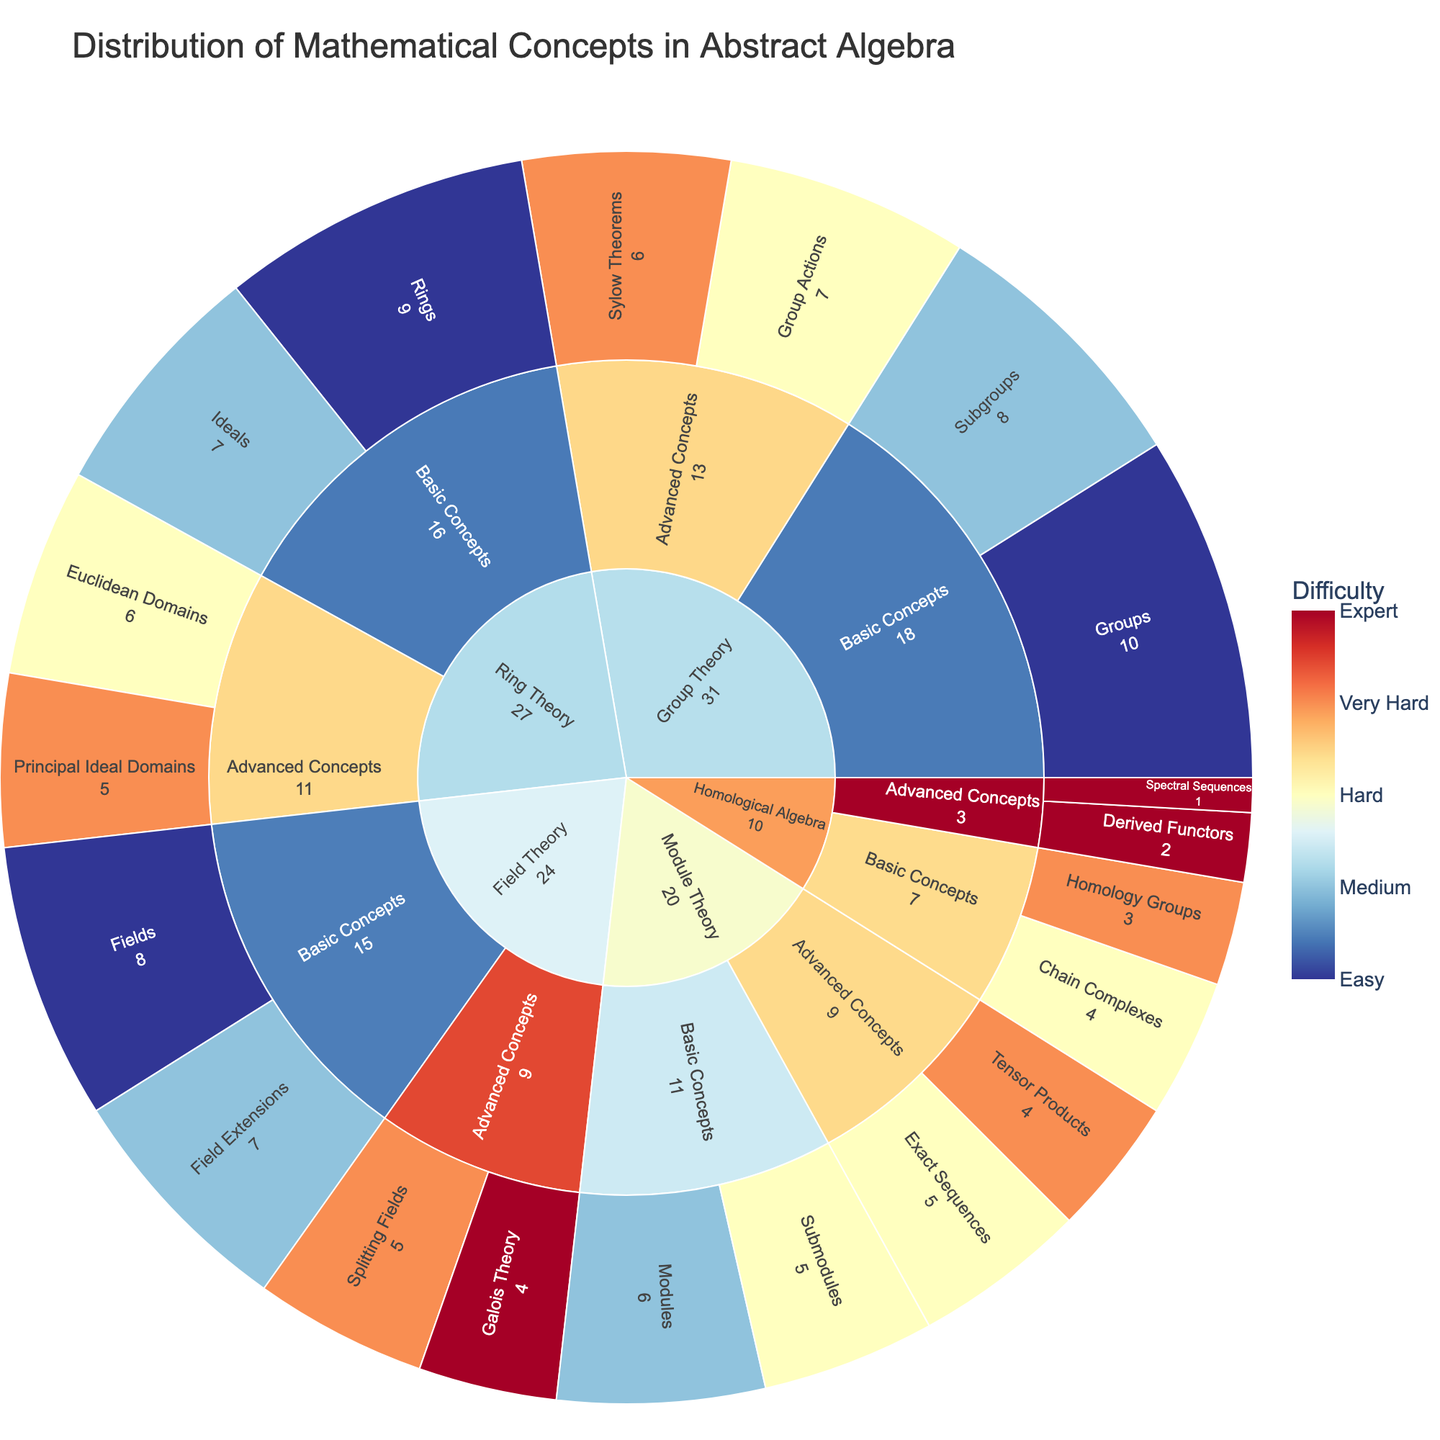What is the title of the plot? The title is usually at the top of the figure.
Answer: Distribution of Mathematical Concepts in Abstract Algebra Which category has the highest value of concepts? Check the outermost ring and sum values for each category: Group Theory, Ring Theory, Field Theory, Module Theory, Homological Algebra. Compare the sums.
Answer: Group Theory What are the subcategories of Group Theory? Look at the subfield divisions within the Group Theory section.
Answer: Basic Concepts, Advanced Concepts What is the color representation for the highest difficulty level? Locate the color bar, find the color corresponding to 'Expert' (level 5).
Answer: Dark Blue Which subfield in Field Theory has the lowest value of concepts? In Field Theory's section, compare values of subcategories: Basic Concepts, Advanced Concepts.
Answer: Advanced Concepts How many concepts are at the difficulty level of 4 in the entire plot? Identify all labels marked with '4' (difficulty level in hover data), sum their values.
Answer: 19 What is the average value of concepts in the Ring Theory category? Sum values of all concepts in Ring Theory (9+7+5+6). Count total concepts (4). Calculate average: (27 / 4).
Answer: 6.75 Compare the value of 'Group Actions' and 'Exact Sequences'. Which one is higher? Find ‘Group Actions’ under Group Theory and 'Exact Sequences' under Module Theory. Compare values (7 vs 5).
Answer: Group Actions Which concept has the lowest value and what is its difficulty level? Locate the concept with the smallest segment (smallest number), read difficulty level from hover data.
Answer: Spectral Sequences, level 5 Is the 'Submodules' concept more difficult than the 'Modules' concept? Find both concepts under Module Theory, compare difficulty levels in hover data: ‘Submodules’ (3) vs ‘Modules’ (2).
Answer: Yes 